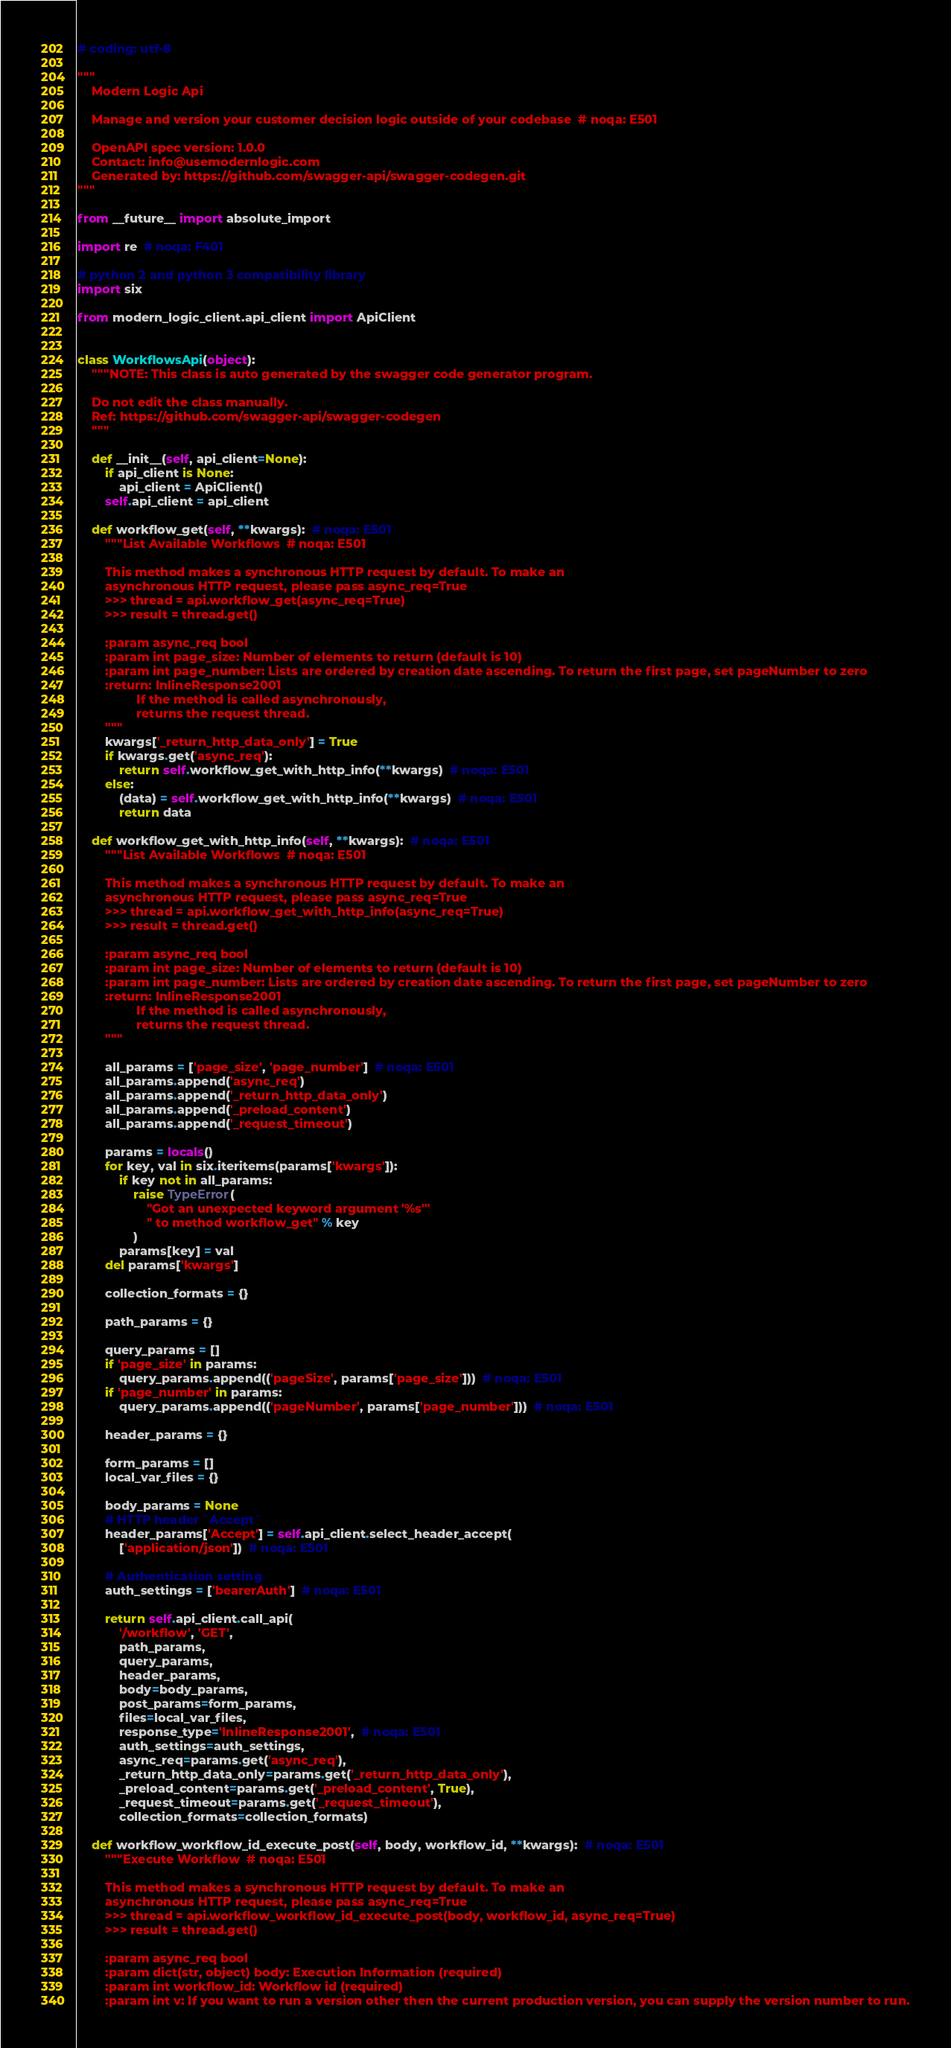Convert code to text. <code><loc_0><loc_0><loc_500><loc_500><_Python_># coding: utf-8

"""
    Modern Logic Api

    Manage and version your customer decision logic outside of your codebase  # noqa: E501

    OpenAPI spec version: 1.0.0
    Contact: info@usemodernlogic.com
    Generated by: https://github.com/swagger-api/swagger-codegen.git
"""

from __future__ import absolute_import

import re  # noqa: F401

# python 2 and python 3 compatibility library
import six

from modern_logic_client.api_client import ApiClient


class WorkflowsApi(object):
    """NOTE: This class is auto generated by the swagger code generator program.

    Do not edit the class manually.
    Ref: https://github.com/swagger-api/swagger-codegen
    """

    def __init__(self, api_client=None):
        if api_client is None:
            api_client = ApiClient()
        self.api_client = api_client

    def workflow_get(self, **kwargs):  # noqa: E501
        """List Available Workflows  # noqa: E501

        This method makes a synchronous HTTP request by default. To make an
        asynchronous HTTP request, please pass async_req=True
        >>> thread = api.workflow_get(async_req=True)
        >>> result = thread.get()

        :param async_req bool
        :param int page_size: Number of elements to return (default is 10)
        :param int page_number: Lists are ordered by creation date ascending. To return the first page, set pageNumber to zero
        :return: InlineResponse2001
                 If the method is called asynchronously,
                 returns the request thread.
        """
        kwargs['_return_http_data_only'] = True
        if kwargs.get('async_req'):
            return self.workflow_get_with_http_info(**kwargs)  # noqa: E501
        else:
            (data) = self.workflow_get_with_http_info(**kwargs)  # noqa: E501
            return data

    def workflow_get_with_http_info(self, **kwargs):  # noqa: E501
        """List Available Workflows  # noqa: E501

        This method makes a synchronous HTTP request by default. To make an
        asynchronous HTTP request, please pass async_req=True
        >>> thread = api.workflow_get_with_http_info(async_req=True)
        >>> result = thread.get()

        :param async_req bool
        :param int page_size: Number of elements to return (default is 10)
        :param int page_number: Lists are ordered by creation date ascending. To return the first page, set pageNumber to zero
        :return: InlineResponse2001
                 If the method is called asynchronously,
                 returns the request thread.
        """

        all_params = ['page_size', 'page_number']  # noqa: E501
        all_params.append('async_req')
        all_params.append('_return_http_data_only')
        all_params.append('_preload_content')
        all_params.append('_request_timeout')

        params = locals()
        for key, val in six.iteritems(params['kwargs']):
            if key not in all_params:
                raise TypeError(
                    "Got an unexpected keyword argument '%s'"
                    " to method workflow_get" % key
                )
            params[key] = val
        del params['kwargs']

        collection_formats = {}

        path_params = {}

        query_params = []
        if 'page_size' in params:
            query_params.append(('pageSize', params['page_size']))  # noqa: E501
        if 'page_number' in params:
            query_params.append(('pageNumber', params['page_number']))  # noqa: E501

        header_params = {}

        form_params = []
        local_var_files = {}

        body_params = None
        # HTTP header `Accept`
        header_params['Accept'] = self.api_client.select_header_accept(
            ['application/json'])  # noqa: E501

        # Authentication setting
        auth_settings = ['bearerAuth']  # noqa: E501

        return self.api_client.call_api(
            '/workflow', 'GET',
            path_params,
            query_params,
            header_params,
            body=body_params,
            post_params=form_params,
            files=local_var_files,
            response_type='InlineResponse2001',  # noqa: E501
            auth_settings=auth_settings,
            async_req=params.get('async_req'),
            _return_http_data_only=params.get('_return_http_data_only'),
            _preload_content=params.get('_preload_content', True),
            _request_timeout=params.get('_request_timeout'),
            collection_formats=collection_formats)

    def workflow_workflow_id_execute_post(self, body, workflow_id, **kwargs):  # noqa: E501
        """Execute Workflow  # noqa: E501

        This method makes a synchronous HTTP request by default. To make an
        asynchronous HTTP request, please pass async_req=True
        >>> thread = api.workflow_workflow_id_execute_post(body, workflow_id, async_req=True)
        >>> result = thread.get()

        :param async_req bool
        :param dict(str, object) body: Execution Information (required)
        :param int workflow_id: Workflow id (required)
        :param int v: If you want to run a version other then the current production version, you can supply the version number to run.</code> 